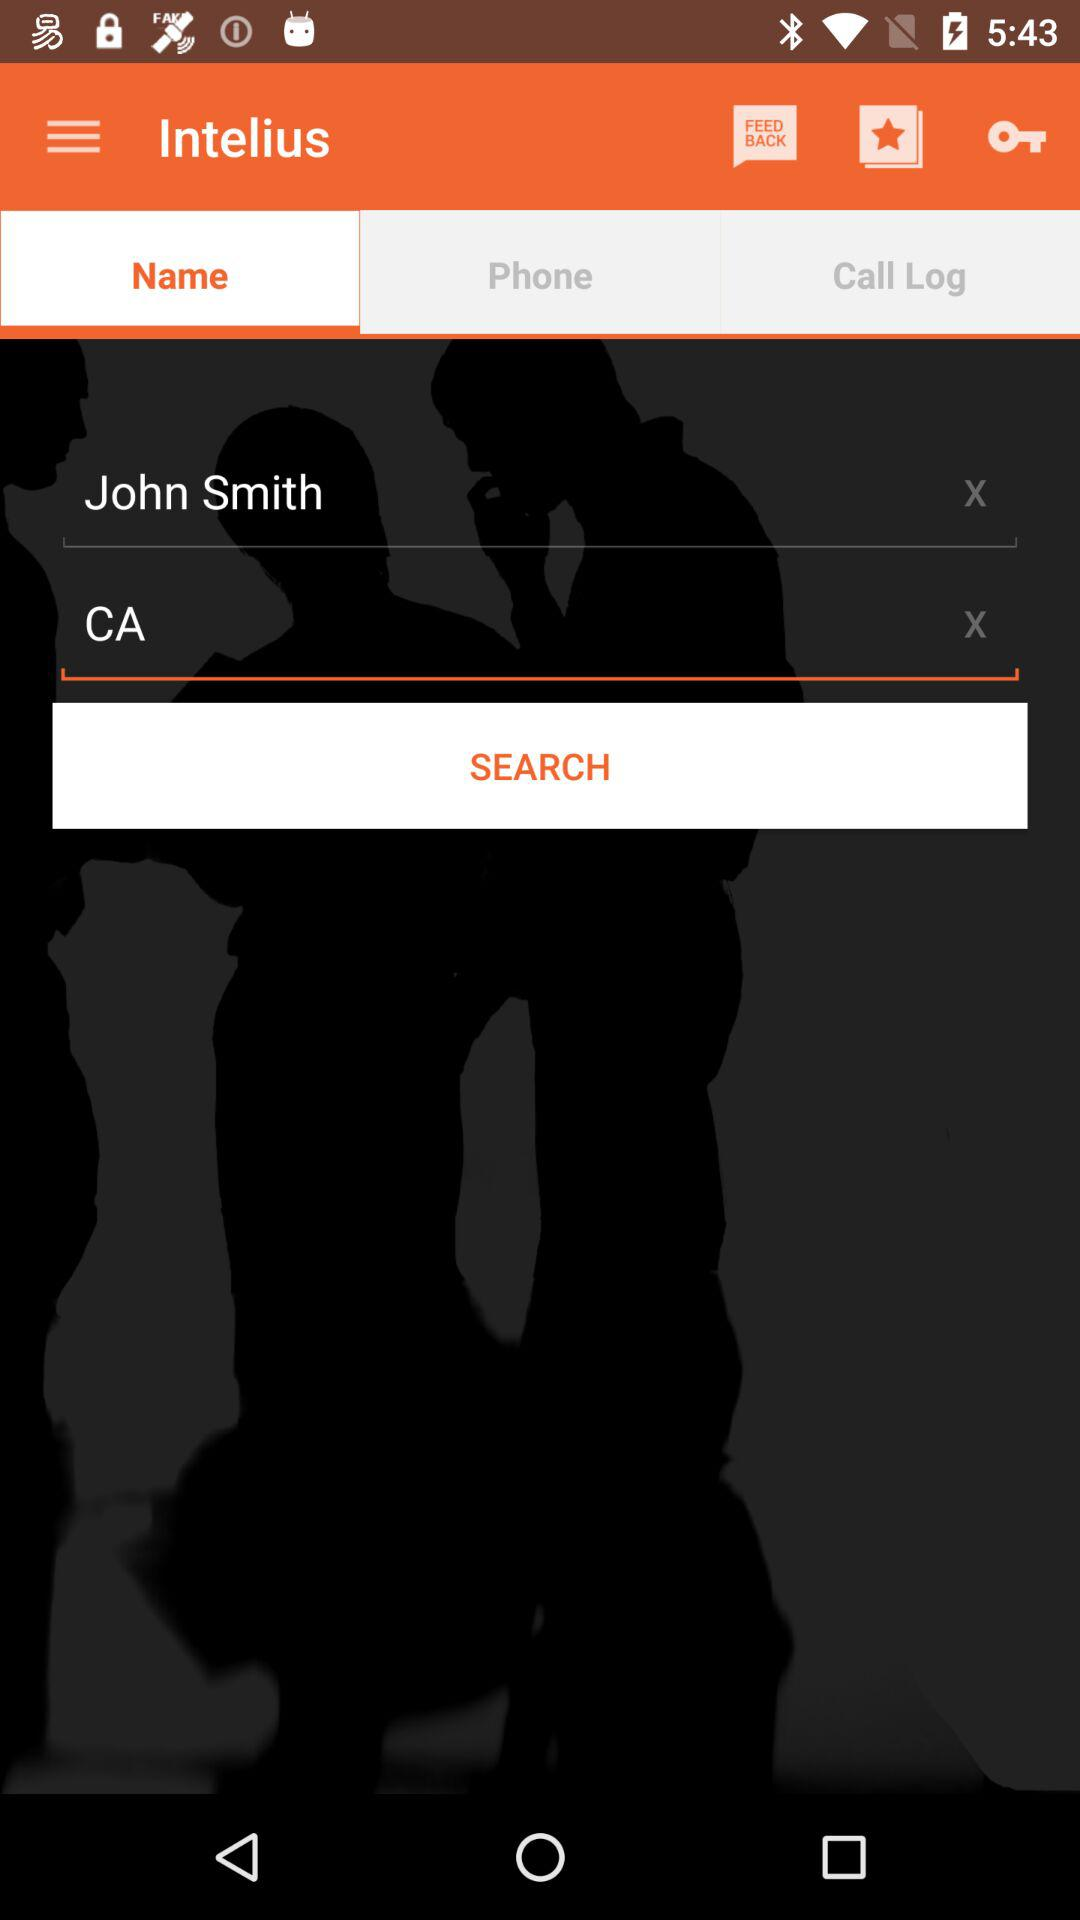What is the location? The location is "CA". 